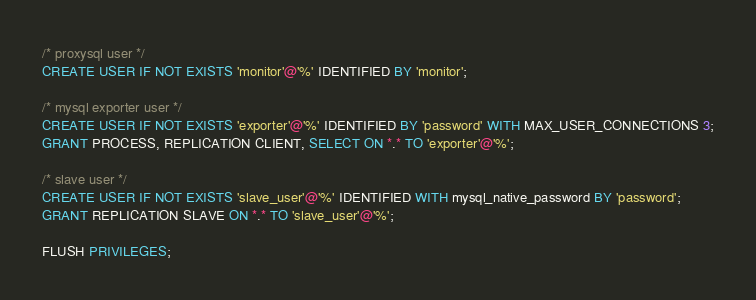<code> <loc_0><loc_0><loc_500><loc_500><_SQL_>/* proxysql user */
CREATE USER IF NOT EXISTS 'monitor'@'%' IDENTIFIED BY 'monitor';

/* mysql exporter user */
CREATE USER IF NOT EXISTS 'exporter'@'%' IDENTIFIED BY 'password' WITH MAX_USER_CONNECTIONS 3;
GRANT PROCESS, REPLICATION CLIENT, SELECT ON *.* TO 'exporter'@'%';

/* slave user */
CREATE USER IF NOT EXISTS 'slave_user'@'%' IDENTIFIED WITH mysql_native_password BY 'password';
GRANT REPLICATION SLAVE ON *.* TO 'slave_user'@'%';

FLUSH PRIVILEGES;
</code> 